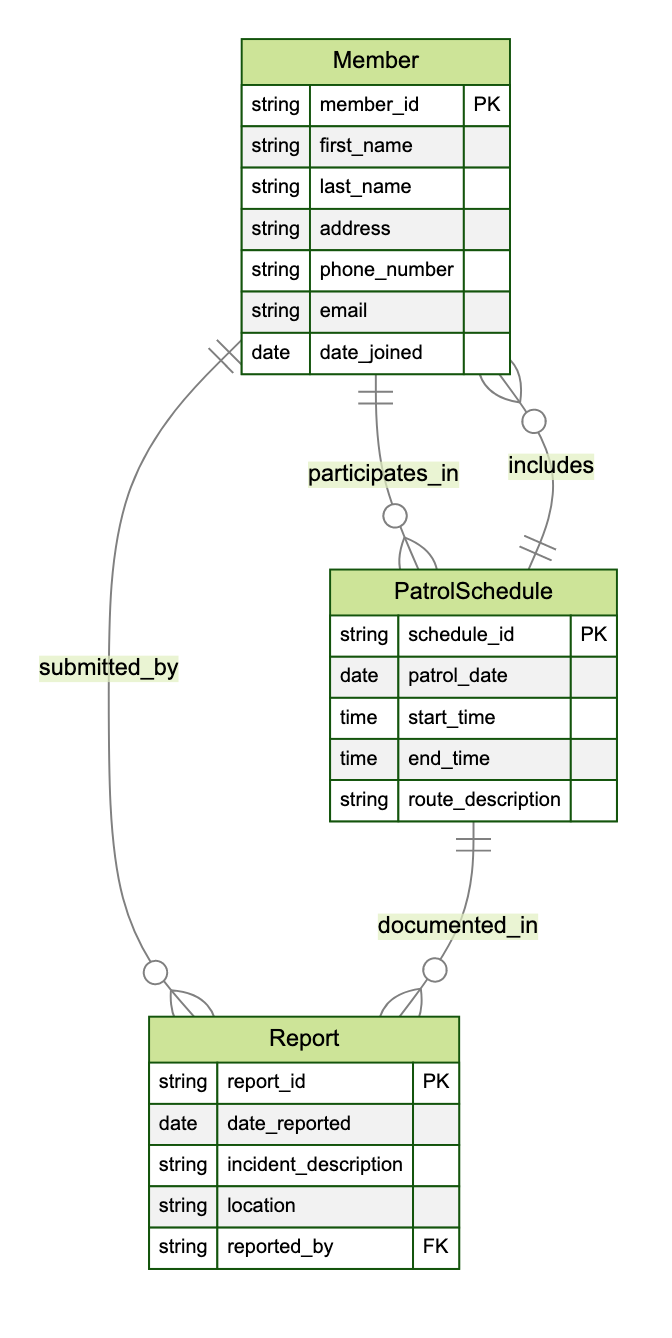What is the primary key of the Member entity? The primary key of the Member entity is identified as "member_id," which uniquely identifies each member in the Neighborhood Watch Program.
Answer: member_id How many attributes does the Report entity have? The Report entity has five attributes: report_id, date_reported, incident_description, location, and reported_by, which can be counted directly from the diagram.
Answer: 5 Which entity is related to PatrolSchedule through the relationship "documented_in"? The Report entity is related to PatrolSchedule through the "documented_in" relationship, indicating that the report is associated with a specific patrol schedule.
Answer: Report How many relationships does the Member entity participate in? The Member entity participates in two relationships: "participates_in" with PatrolSchedule and "submitted_by" with Report, allowing us to count the connections directly from the diagram.
Answer: 2 What attribute in the Report entity indicates who submitted the report? The attribute "reported_by" in the Report entity indicates the member who submitted the report, directly linking it to the Member entity through their identification.
Answer: reported_by In which relationship does PatrolSchedule include Members? PatrolSchedule includes Members through the "includes" relationship, signifying that multiple members can be part of a patrol schedule, as noted in the diagram.
Answer: includes What is the relationship type between Member and Report? The relationship between Member and Report is defined as "submitted_by," which shows that members submit reports regarding incidents, as indicated in the diagram.
Answer: submitted_by What attribute describes the date of a patrol? The attribute "patrol_date" in the PatrolSchedule entity describes the date on which a patrol is scheduled to take place, as shown in the diagram.
Answer: patrol_date How many entities are included in this Entity Relationship Diagram? There are three entities in this Entity Relationship Diagram: Member, PatrolSchedule, and Report, which can be counted directly from the entity list.
Answer: 3 